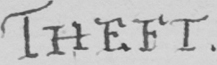Please transcribe the handwritten text in this image. THEFT 